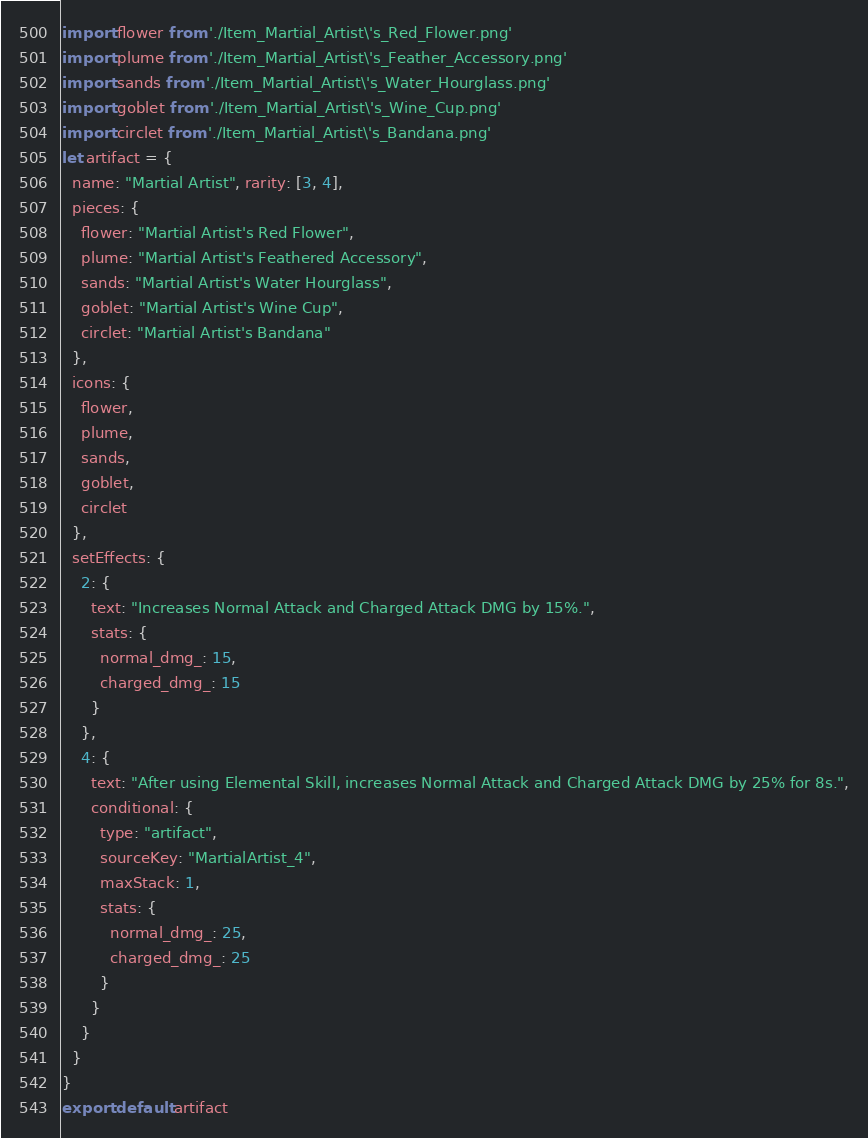<code> <loc_0><loc_0><loc_500><loc_500><_JavaScript_>import flower from './Item_Martial_Artist\'s_Red_Flower.png'
import plume from './Item_Martial_Artist\'s_Feather_Accessory.png'
import sands from './Item_Martial_Artist\'s_Water_Hourglass.png'
import goblet from './Item_Martial_Artist\'s_Wine_Cup.png'
import circlet from './Item_Martial_Artist\'s_Bandana.png'
let artifact = {
  name: "Martial Artist", rarity: [3, 4],
  pieces: {
    flower: "Martial Artist's Red Flower",
    plume: "Martial Artist's Feathered Accessory",
    sands: "Martial Artist's Water Hourglass",
    goblet: "Martial Artist's Wine Cup",
    circlet: "Martial Artist's Bandana"
  },
  icons: {
    flower,
    plume,
    sands,
    goblet,
    circlet
  },
  setEffects: {
    2: {
      text: "Increases Normal Attack and Charged Attack DMG by 15%.",
      stats: {
        normal_dmg_: 15,
        charged_dmg_: 15
      }
    },
    4: {
      text: "After using Elemental Skill, increases Normal Attack and Charged Attack DMG by 25% for 8s.",
      conditional: {
        type: "artifact",
        sourceKey: "MartialArtist_4",
        maxStack: 1,
        stats: {
          normal_dmg_: 25,
          charged_dmg_: 25
        }
      }
    }
  }
}
export default artifact</code> 